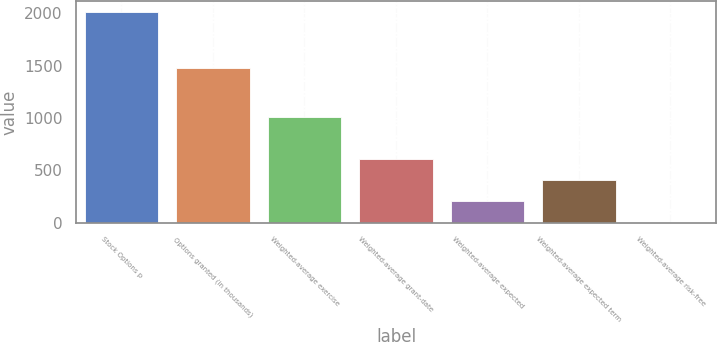<chart> <loc_0><loc_0><loc_500><loc_500><bar_chart><fcel>Stock Options p<fcel>Options granted (in thousands)<fcel>Weighted-average exercise<fcel>Weighted-average grant-date<fcel>Weighted-average expected<fcel>Weighted-average expected term<fcel>Weighted-average risk-free<nl><fcel>2017<fcel>1480<fcel>1009.55<fcel>606.57<fcel>203.59<fcel>405.08<fcel>2.1<nl></chart> 